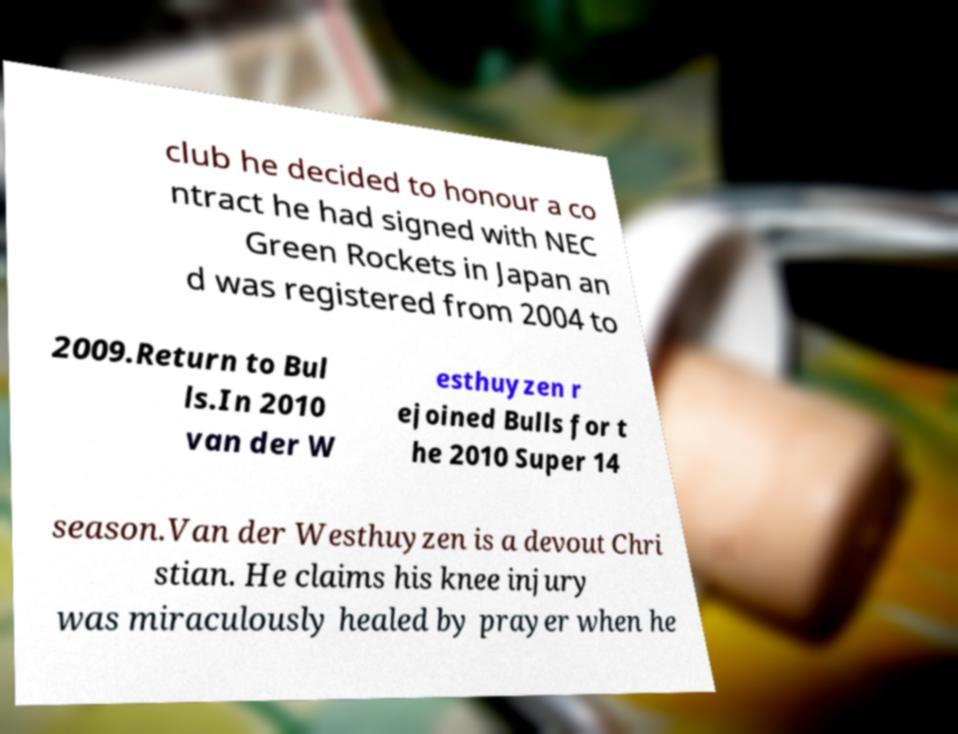Can you accurately transcribe the text from the provided image for me? club he decided to honour a co ntract he had signed with NEC Green Rockets in Japan an d was registered from 2004 to 2009.Return to Bul ls.In 2010 van der W esthuyzen r ejoined Bulls for t he 2010 Super 14 season.Van der Westhuyzen is a devout Chri stian. He claims his knee injury was miraculously healed by prayer when he 